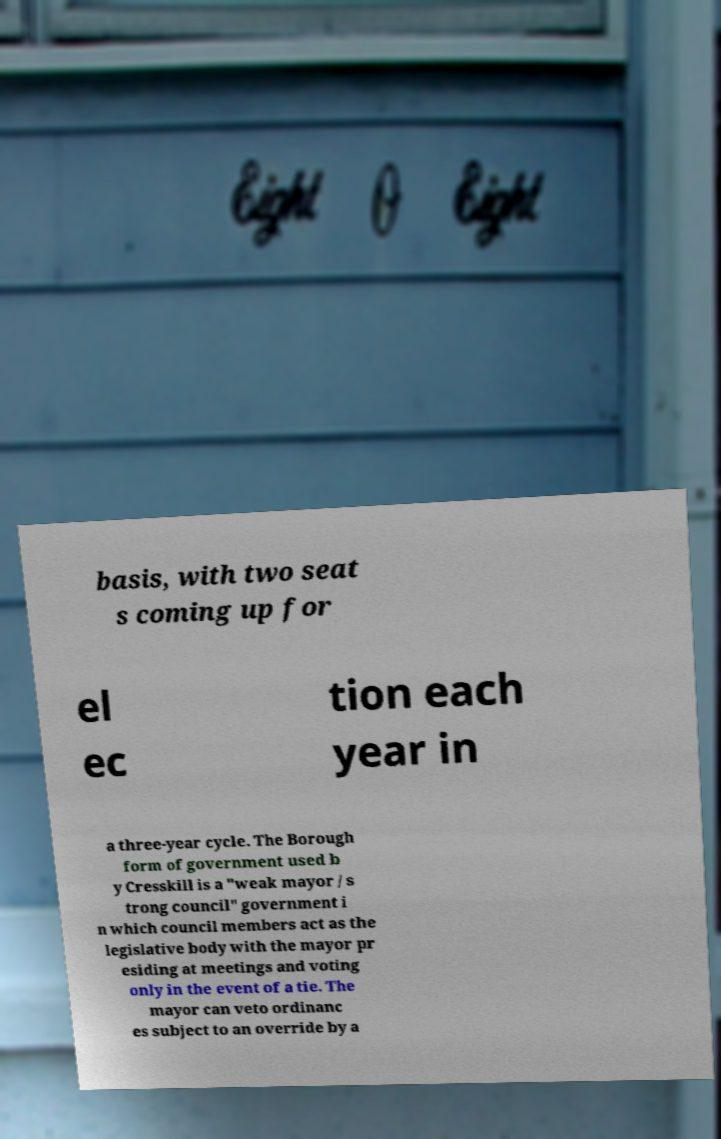For documentation purposes, I need the text within this image transcribed. Could you provide that? basis, with two seat s coming up for el ec tion each year in a three-year cycle. The Borough form of government used b y Cresskill is a "weak mayor / s trong council" government i n which council members act as the legislative body with the mayor pr esiding at meetings and voting only in the event of a tie. The mayor can veto ordinanc es subject to an override by a 